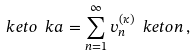Convert formula to latex. <formula><loc_0><loc_0><loc_500><loc_500>\ k e t o { \ k a } = \sum _ { n = 1 } ^ { \infty } v _ { n } ^ { ( \kappa ) } \ k e t o { n } \, ,</formula> 